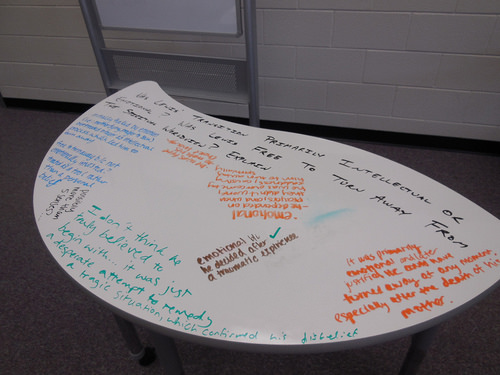<image>
Is the writing on the table? Yes. Looking at the image, I can see the writing is positioned on top of the table, with the table providing support. 